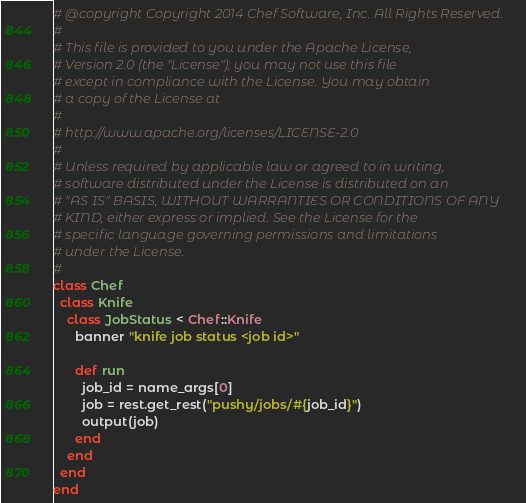<code> <loc_0><loc_0><loc_500><loc_500><_Ruby_># @copyright Copyright 2014 Chef Software, Inc. All Rights Reserved.
#
# This file is provided to you under the Apache License,
# Version 2.0 (the "License"); you may not use this file
# except in compliance with the License. You may obtain
# a copy of the License at
#
# http://www.apache.org/licenses/LICENSE-2.0
#
# Unless required by applicable law or agreed to in writing,
# software distributed under the License is distributed on an
# "AS IS" BASIS, WITHOUT WARRANTIES OR CONDITIONS OF ANY
# KIND, either express or implied. See the License for the
# specific language governing permissions and limitations
# under the License.
#
class Chef
  class Knife
    class JobStatus < Chef::Knife
      banner "knife job status <job id>"

      def run
        job_id = name_args[0]
        job = rest.get_rest("pushy/jobs/#{job_id}")
        output(job)
      end
    end
  end
end
</code> 